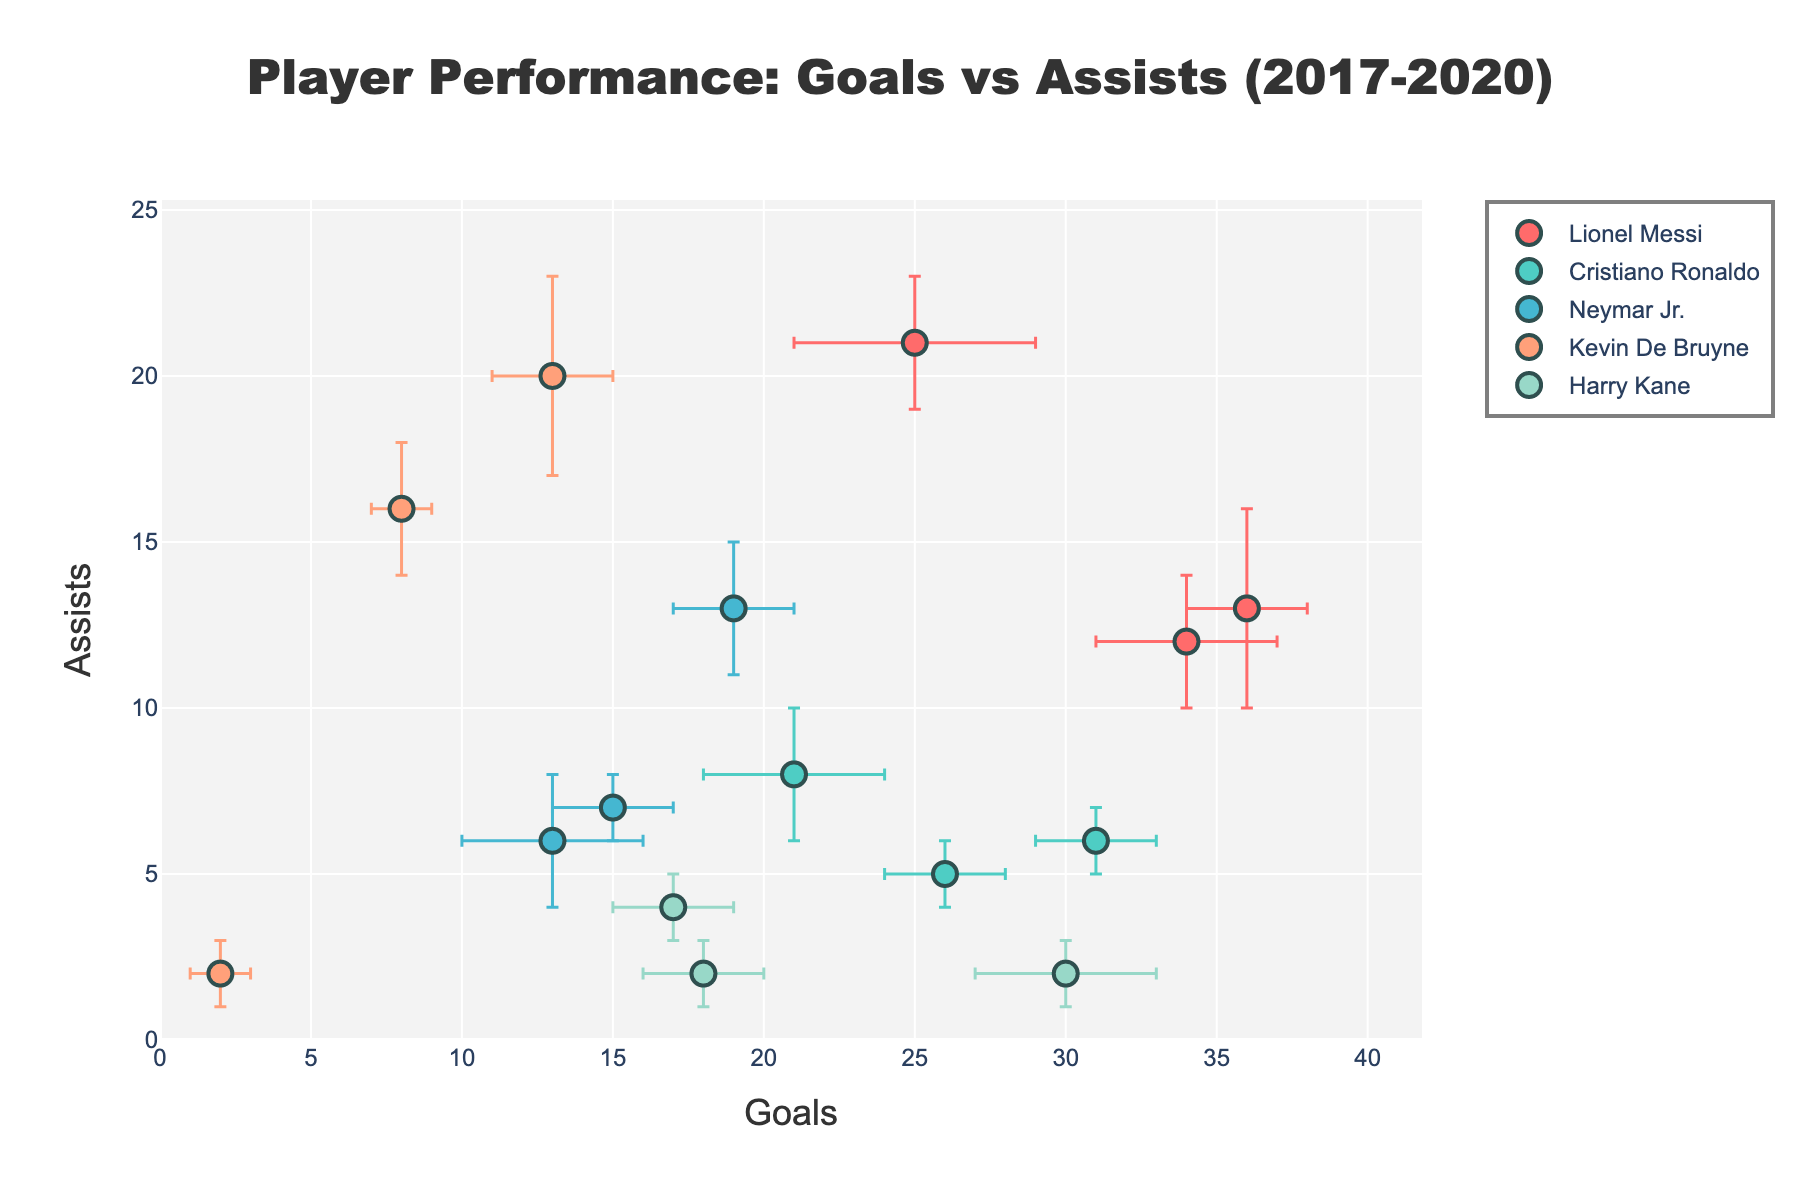What's the title of the figure? The title usually appears at the top of the chart and is meant to provide a summary of what the figure represents. In this case, the title is situated centrally at the top.
Answer: Player Performance: Goals vs Assists (2017-2020) How many players are shown in the figure? The number of unique names in the legend represents the number of players. Each player has a distinct color assigned to them.
Answer: 5 Which player had the highest number of goals in the 2018-2019 season? By hovering over the points in the figure, you can see the season associated with each data point. Lionel Messi’s point for the 2018-2019 season has the highest x-value (goals).
Answer: Lionel Messi How does Neymar Jr.'s assist performance change from 2017-2018 to 2019-2020? Find Neymar Jr.'s data points for the specified seasons and compare their y-values (assists). His assists decreased from 13 in 2017-2018 to 6 in 2019-2020.
Answer: Decreases What is the difference in goals between Cristiano Ronaldo's 2019-2020 and 2018-2019 seasons? Cristiano Ronaldo's goals in 2019-2020 are 31 and in 2018-2019 are 21. The difference is 31 - 21.
Answer: 10 Who recorded the highest number of assists in any single season, and what was the value? Identify the data point with the highest y-value (assists) across all players and seasons. Kevin De Bruyne in the 2019-2020 season has the highest assists at 20.
Answer: Kevin De Bruyne, 21 Which player has the most variability in goals, based on the error bars? Compare the length of the error bars (horizontal). Lionel Messi and Neymar Jr. both have a maximum error bar for goals of 4, but Lionel Messi has more consistent appearances at the high goal range.
Answer: Lionel Messi and Neymar Jr Calculate the average number of goals scored by Harry Kane over the three seasons. Sum the goals scored by Harry Kane in each of the three seasons: 30 (2017-2018), 17 (2018-2019), and 18 (2019-2020). Then divide by 3. (30 + 17 + 18) / 3 = 65 / 3.
Answer: 21.67 Which player has the smallest error range for assists in any season? Identify the smallest vertical error bar for assists across all players and seasons. Cristiano Ronaldo in 2017-2018 had the smallest assist error range with an error value of 1.
Answer: Cristiano Ronaldo Which season did Kevin De Bruyne have the least performance variability in terms of goals? Look for Kevin De Bruyne’s data points and compare the horizontal error bars. The smallest error bar for goals is in the 2017-2018 season with an error value of 1.
Answer: 2017-2018 